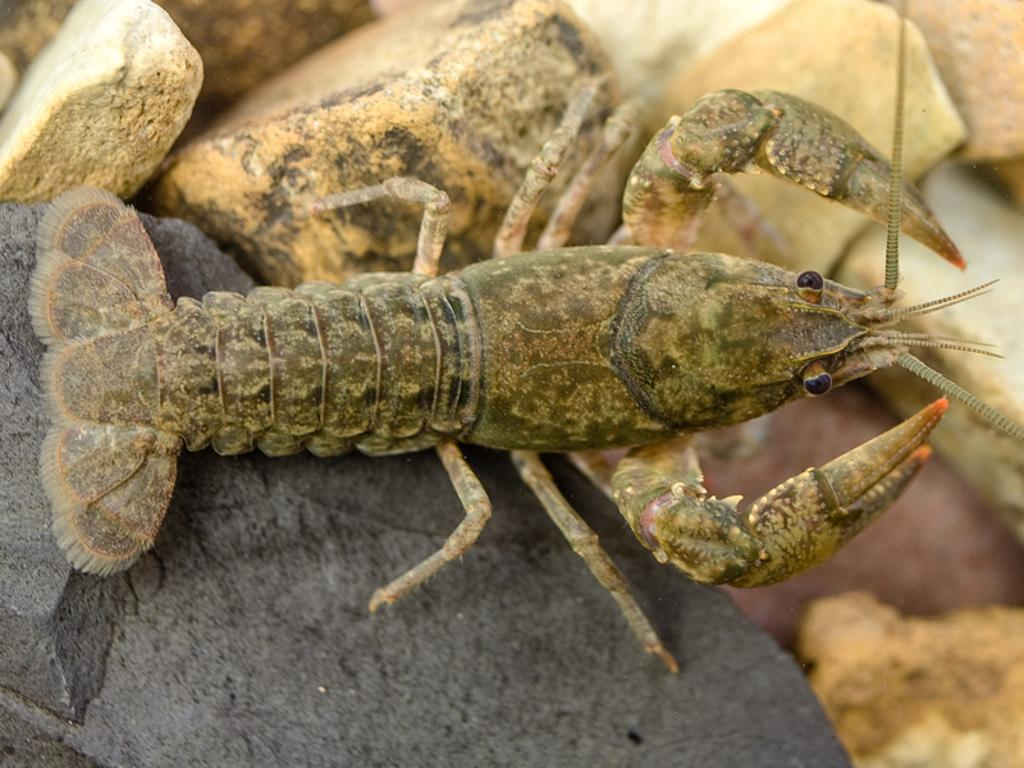What is the main subject of the image? There is a crayfish in the center of the image. Can you describe the background of the image? There are rocks present in the background of the image. Reasoning: Let's think step by step by step in order to produce the conversation. We start by identifying the main subject of the image, which is the crayfish. Then, we describe the background of the image, which includes rocks. Each question is designed to elicit a specific detail about the image that is known from the provided facts. Absurd Question/Answer: What type of cattle can be seen grazing on the earth in the image? There is no cattle present in the image; it features a crayfish and rocks in the background. What type of plough is being used to cultivate the earth in the image? There is no plough or cultivation activity present in the image; it features a crayfish and rocks in the background. 